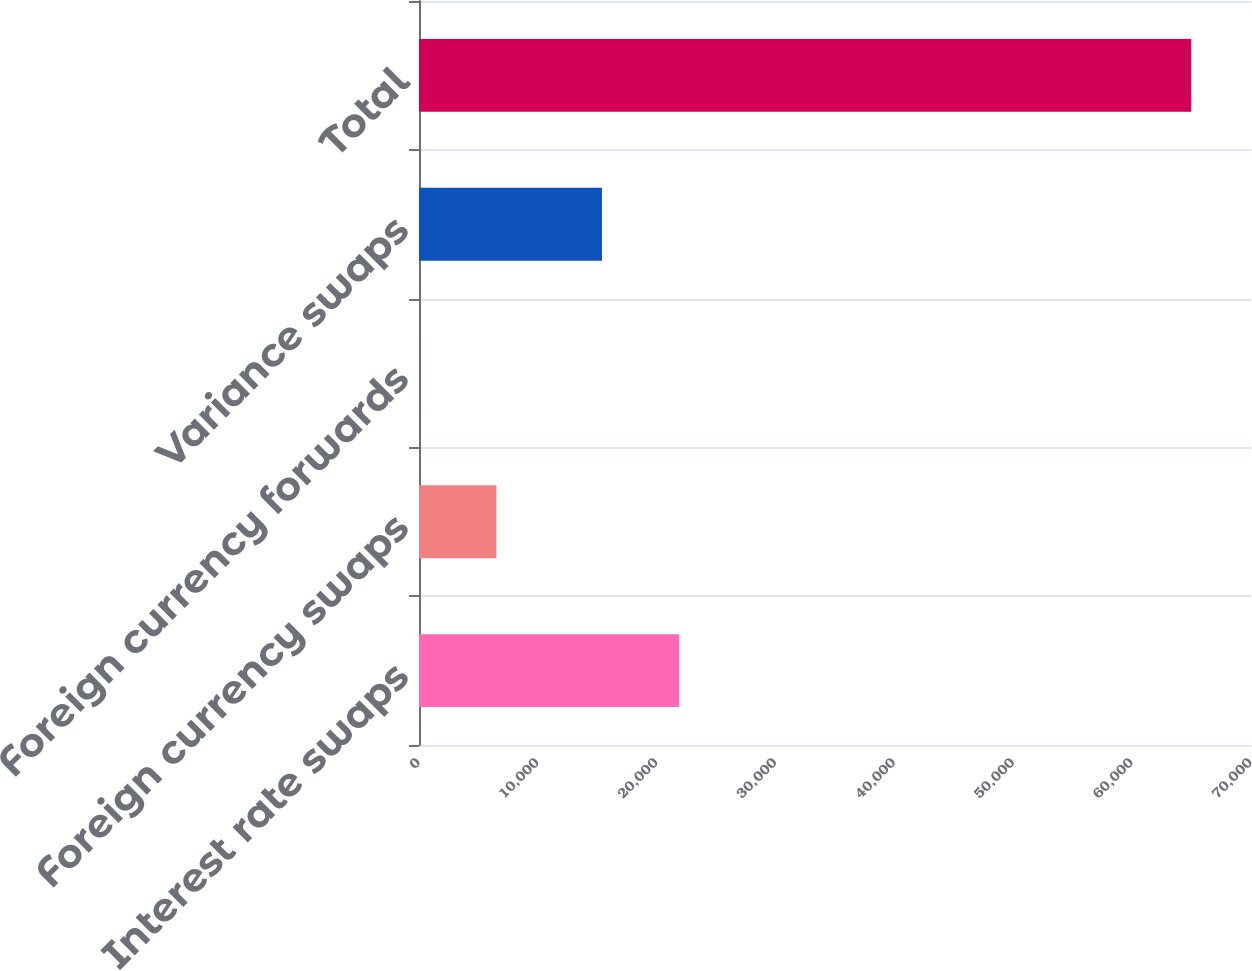Convert chart to OTSL. <chart><loc_0><loc_0><loc_500><loc_500><bar_chart><fcel>Interest rate swaps<fcel>Foreign currency swaps<fcel>Foreign currency forwards<fcel>Variance swaps<fcel>Total<nl><fcel>21891.1<fcel>6514.1<fcel>19<fcel>15396<fcel>64970<nl></chart> 